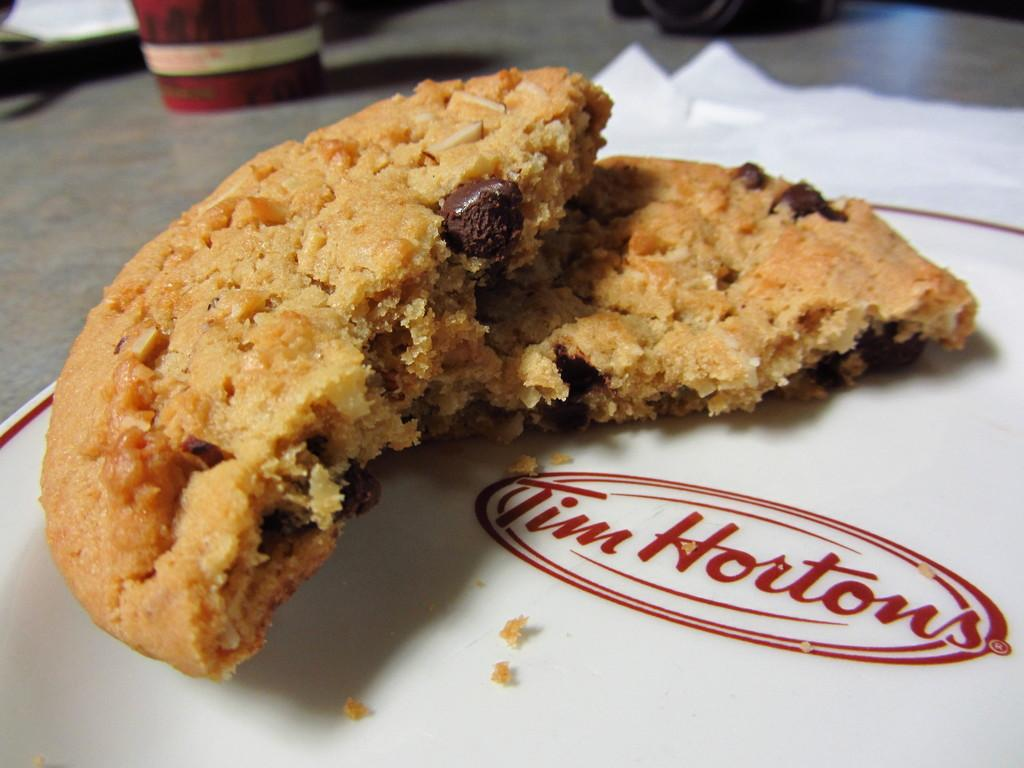What type of food is visible on the paper in the image? There are cookies on a paper in the image. What else can be seen in the image besides the cookies? There is a glass in the image. How many cats are wearing masks in the image? There are no cats or masks present in the image. 